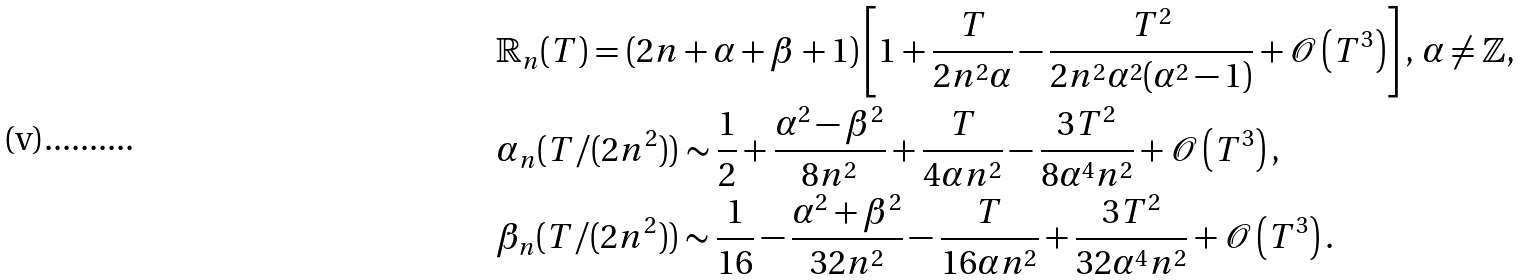Convert formula to latex. <formula><loc_0><loc_0><loc_500><loc_500>& \mathbb { R } _ { n } ( T ) = ( 2 n + \alpha + \beta + 1 ) \left [ 1 + \frac { T } { 2 n ^ { 2 } \alpha } - \frac { T ^ { 2 } } { 2 n ^ { 2 } \alpha ^ { 2 } ( \alpha ^ { 2 } - 1 ) } + \mathcal { O } \left ( T ^ { 3 } \right ) \right ] , \, \alpha \neq \mathbb { Z } , \\ & \alpha _ { n } ( T / ( 2 n ^ { 2 } ) ) \sim \frac { 1 } { 2 } + \frac { \alpha ^ { 2 } - \beta ^ { 2 } } { 8 n ^ { 2 } } + \frac { T } { 4 \alpha n ^ { 2 } } - \frac { 3 T ^ { 2 } } { 8 \alpha ^ { 4 } n ^ { 2 } } + \mathcal { O } \left ( T ^ { 3 } \right ) , \\ & \beta _ { n } ( T / ( 2 n ^ { 2 } ) ) \sim \frac { 1 } { 1 6 } - \frac { \alpha ^ { 2 } + \beta ^ { 2 } } { 3 2 n ^ { 2 } } - \frac { T } { 1 6 \alpha n ^ { 2 } } + \frac { 3 T ^ { 2 } } { 3 2 \alpha ^ { 4 } n ^ { 2 } } + \mathcal { O } \left ( T ^ { 3 } \right ) .</formula> 